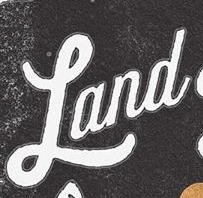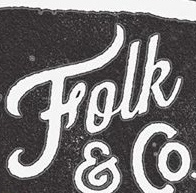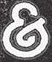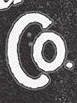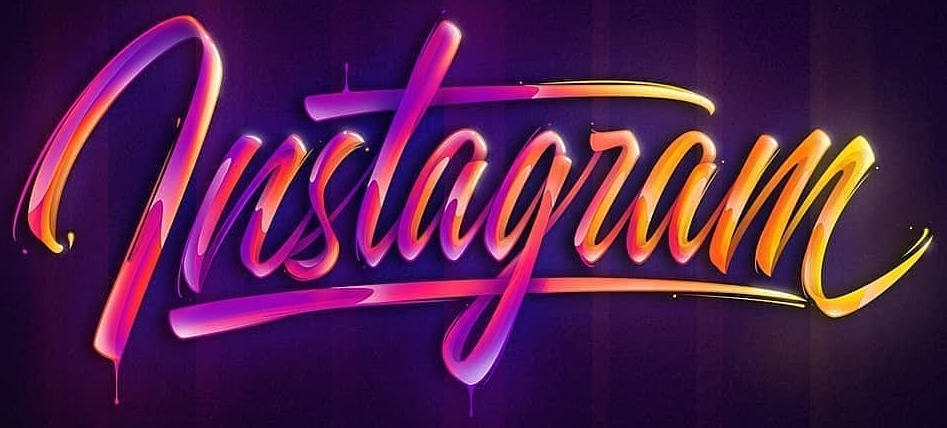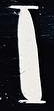Read the text content from these images in order, separated by a semicolon. Land; Folk; &; Co; lnstagram; I 